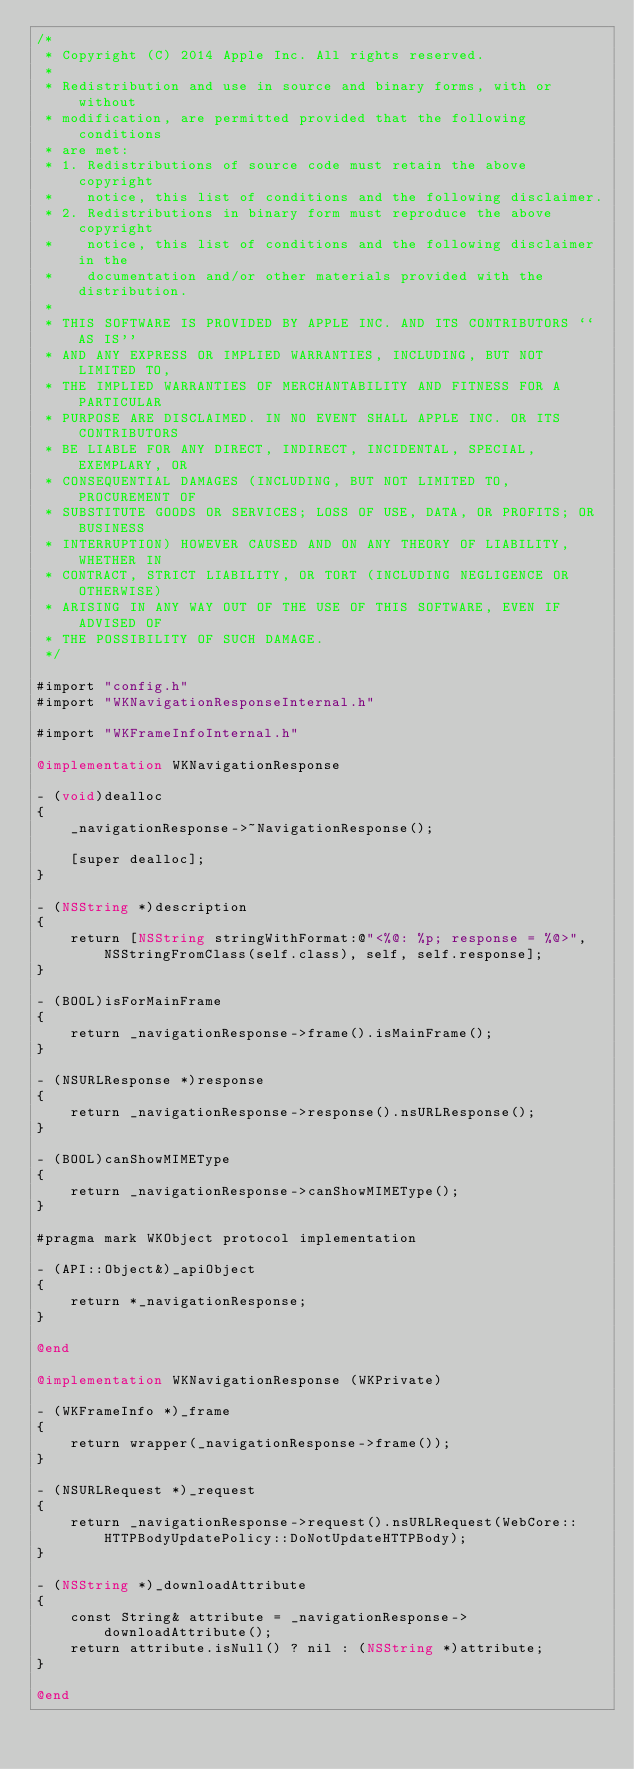<code> <loc_0><loc_0><loc_500><loc_500><_ObjectiveC_>/*
 * Copyright (C) 2014 Apple Inc. All rights reserved.
 *
 * Redistribution and use in source and binary forms, with or without
 * modification, are permitted provided that the following conditions
 * are met:
 * 1. Redistributions of source code must retain the above copyright
 *    notice, this list of conditions and the following disclaimer.
 * 2. Redistributions in binary form must reproduce the above copyright
 *    notice, this list of conditions and the following disclaimer in the
 *    documentation and/or other materials provided with the distribution.
 *
 * THIS SOFTWARE IS PROVIDED BY APPLE INC. AND ITS CONTRIBUTORS ``AS IS''
 * AND ANY EXPRESS OR IMPLIED WARRANTIES, INCLUDING, BUT NOT LIMITED TO,
 * THE IMPLIED WARRANTIES OF MERCHANTABILITY AND FITNESS FOR A PARTICULAR
 * PURPOSE ARE DISCLAIMED. IN NO EVENT SHALL APPLE INC. OR ITS CONTRIBUTORS
 * BE LIABLE FOR ANY DIRECT, INDIRECT, INCIDENTAL, SPECIAL, EXEMPLARY, OR
 * CONSEQUENTIAL DAMAGES (INCLUDING, BUT NOT LIMITED TO, PROCUREMENT OF
 * SUBSTITUTE GOODS OR SERVICES; LOSS OF USE, DATA, OR PROFITS; OR BUSINESS
 * INTERRUPTION) HOWEVER CAUSED AND ON ANY THEORY OF LIABILITY, WHETHER IN
 * CONTRACT, STRICT LIABILITY, OR TORT (INCLUDING NEGLIGENCE OR OTHERWISE)
 * ARISING IN ANY WAY OUT OF THE USE OF THIS SOFTWARE, EVEN IF ADVISED OF
 * THE POSSIBILITY OF SUCH DAMAGE.
 */

#import "config.h"
#import "WKNavigationResponseInternal.h"

#import "WKFrameInfoInternal.h"

@implementation WKNavigationResponse

- (void)dealloc
{
    _navigationResponse->~NavigationResponse();

    [super dealloc];
}

- (NSString *)description
{
    return [NSString stringWithFormat:@"<%@: %p; response = %@>", NSStringFromClass(self.class), self, self.response];
}

- (BOOL)isForMainFrame
{
    return _navigationResponse->frame().isMainFrame();
}

- (NSURLResponse *)response
{
    return _navigationResponse->response().nsURLResponse();
}

- (BOOL)canShowMIMEType
{
    return _navigationResponse->canShowMIMEType();
}

#pragma mark WKObject protocol implementation

- (API::Object&)_apiObject
{
    return *_navigationResponse;
}

@end

@implementation WKNavigationResponse (WKPrivate)

- (WKFrameInfo *)_frame
{
    return wrapper(_navigationResponse->frame());
}

- (NSURLRequest *)_request
{
    return _navigationResponse->request().nsURLRequest(WebCore::HTTPBodyUpdatePolicy::DoNotUpdateHTTPBody);
}

- (NSString *)_downloadAttribute
{
    const String& attribute = _navigationResponse->downloadAttribute();
    return attribute.isNull() ? nil : (NSString *)attribute;
}

@end
</code> 